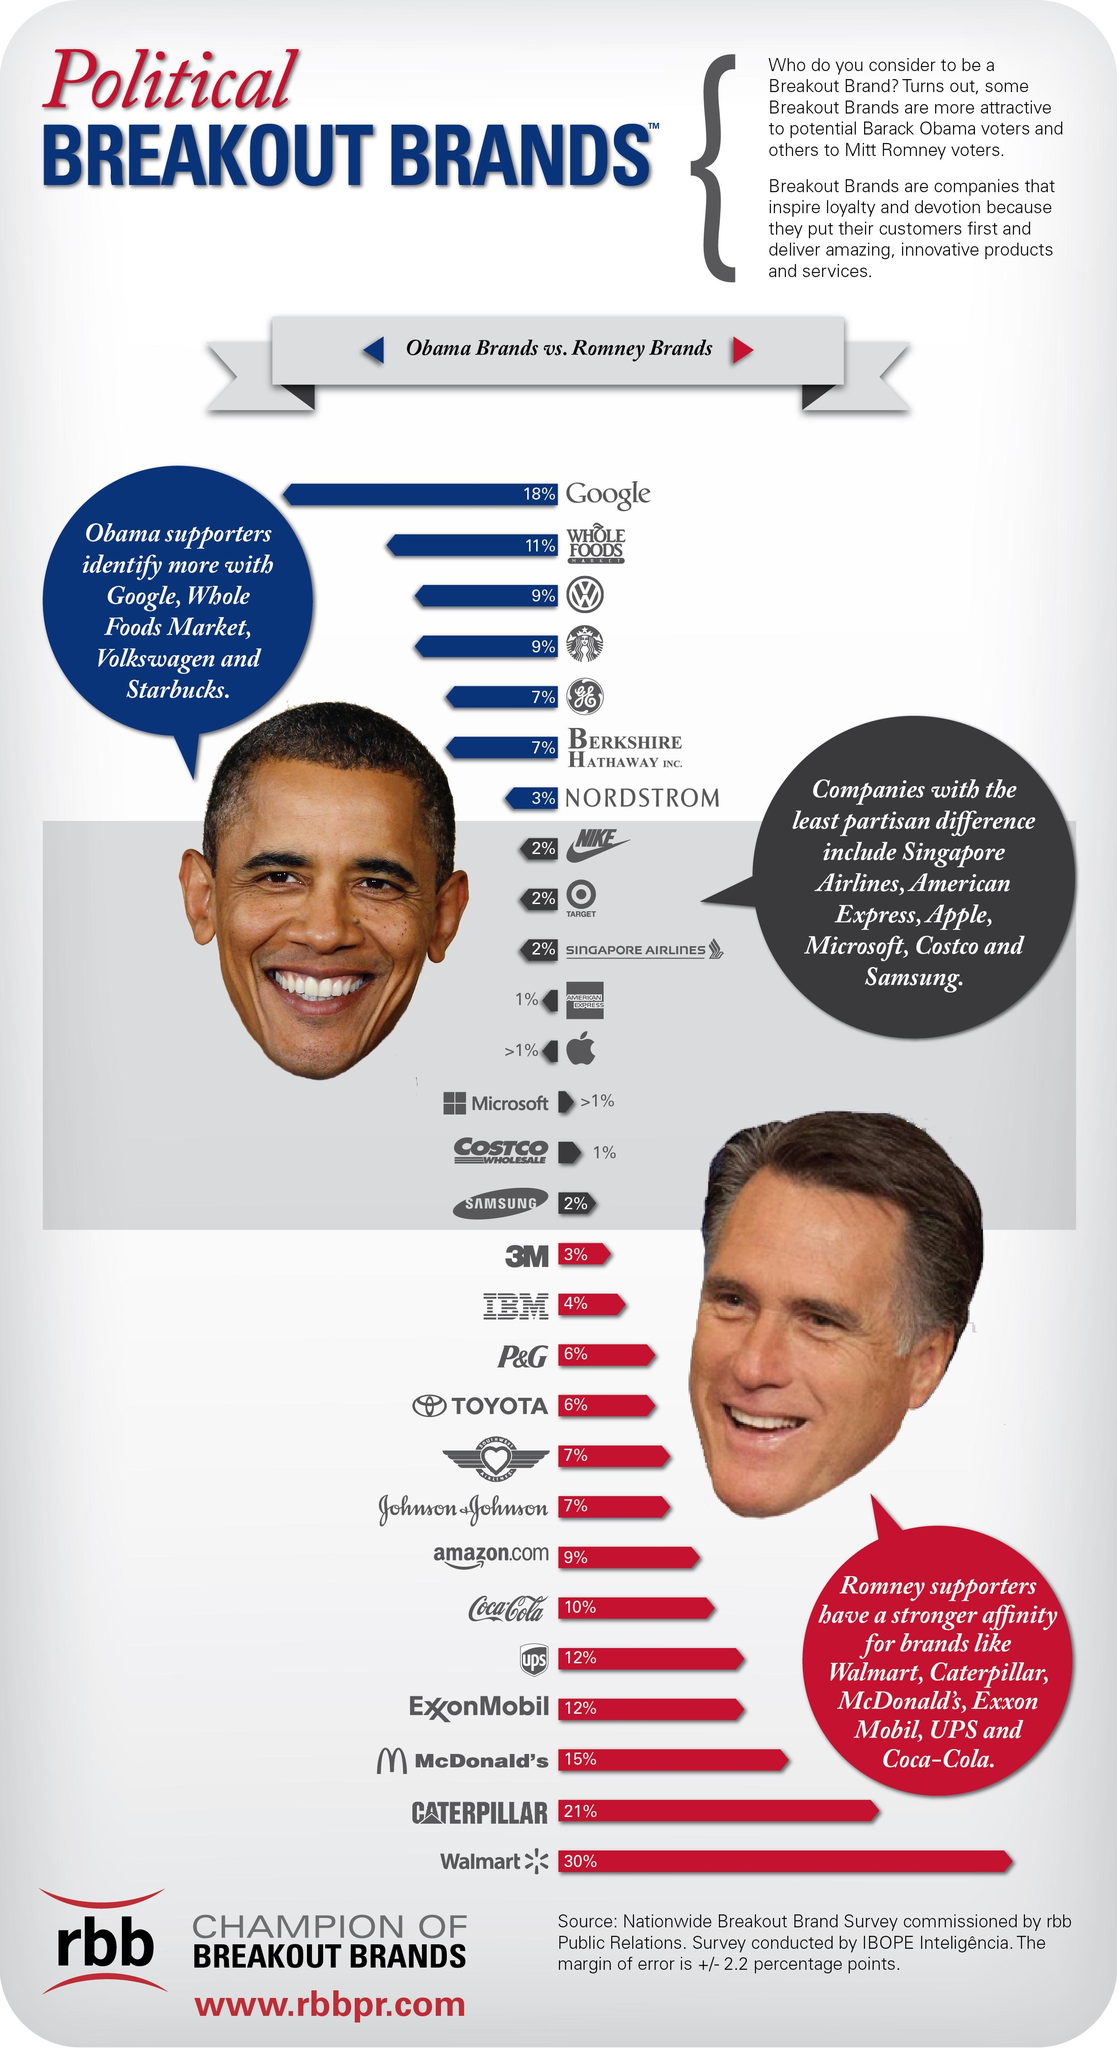List a handful of essential elements in this visual. The picture of Barack Obama is located on the left side of the infographic. The infographic shows a picture of Mitt Romney at the right side. 